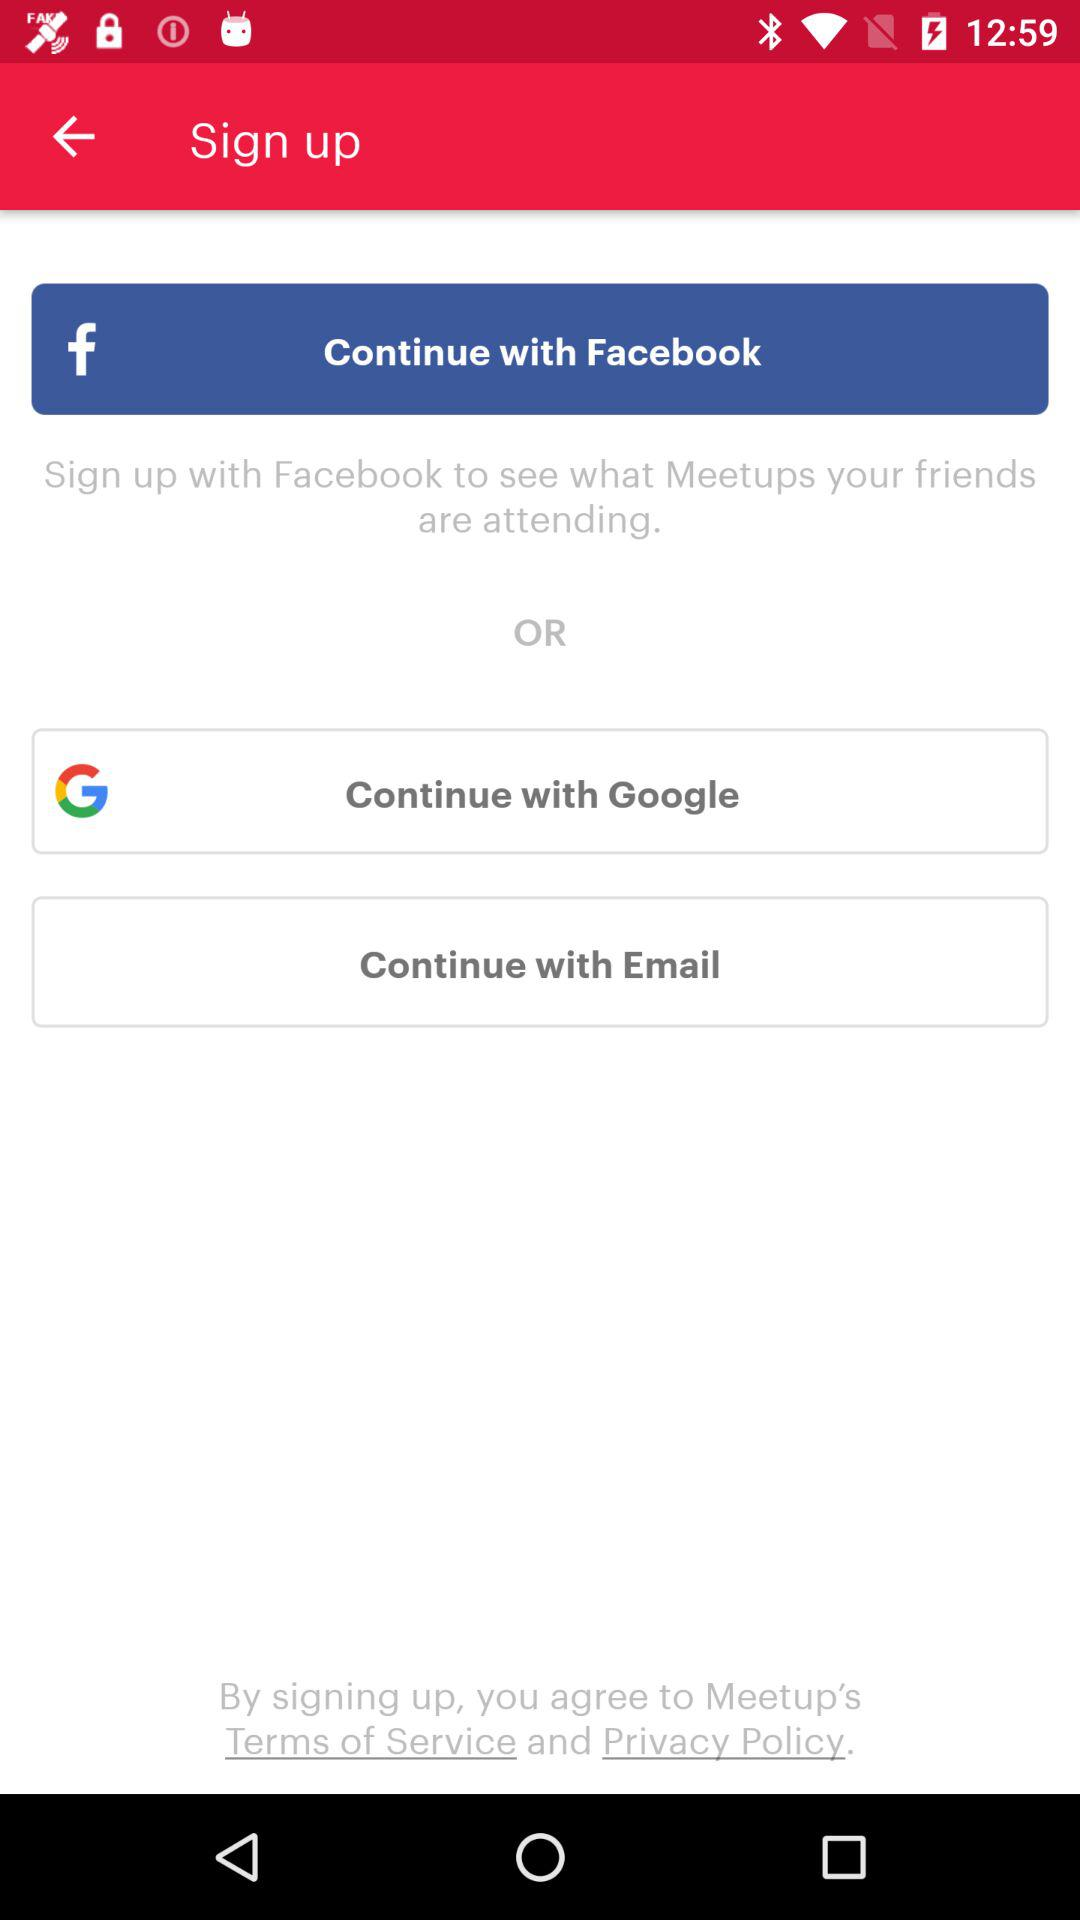Which are the different sign-up options? The different sign-up options are "Facebook", "Google" and "Email". 